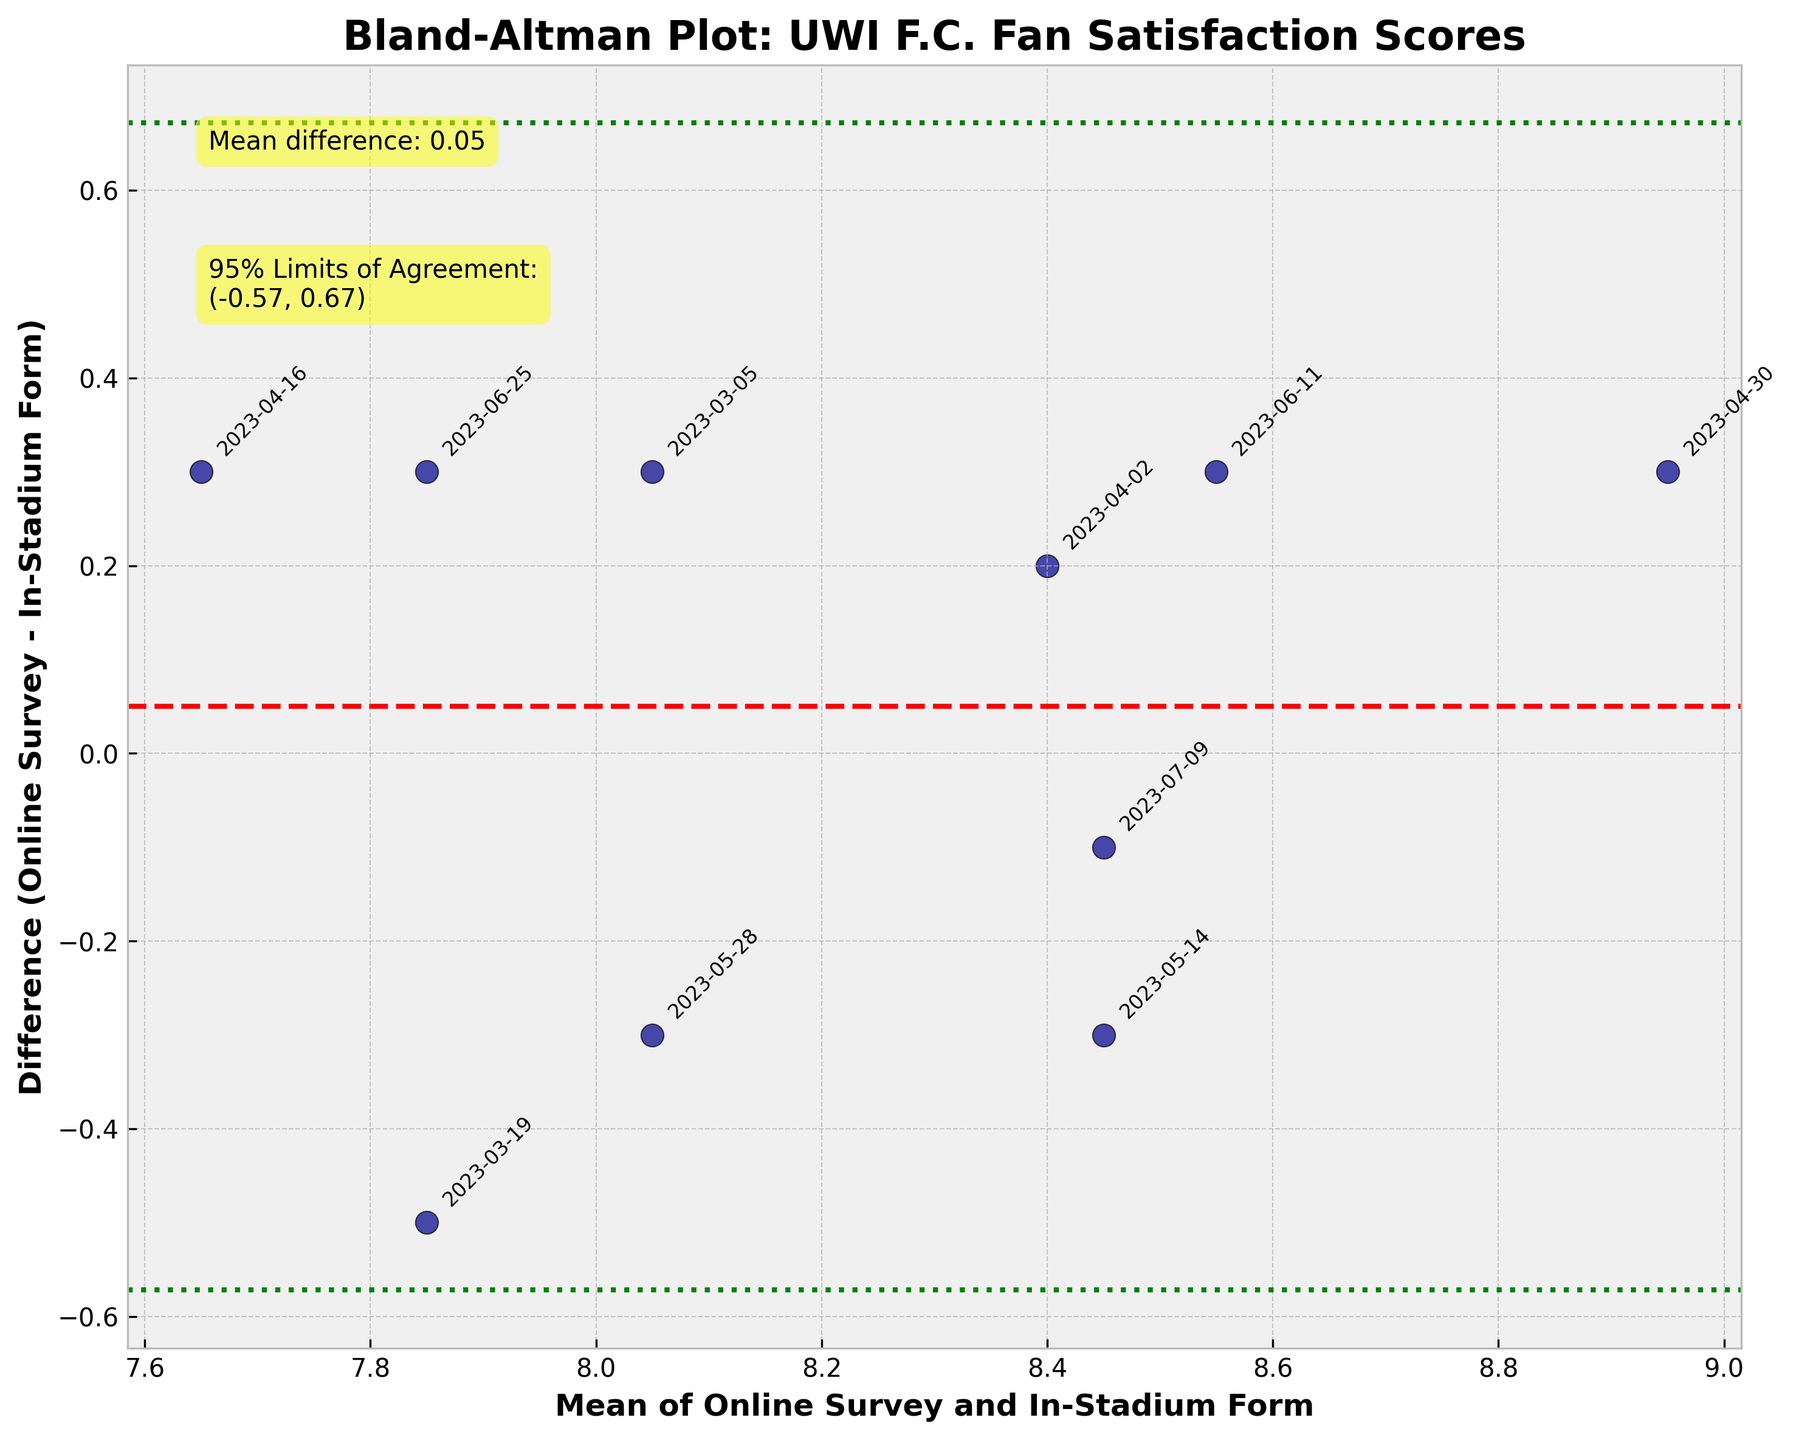How many data points are represented in the plot? By counting the number of points scattered on the plot, we can determine the number of data points. Each point corresponds to a match. There are 10 points on the plot.
Answer: 10 What is the title of the plot? The title of the plot is displayed at the top and usually describes the purpose or subject of the plot. It reads "Bland-Altman Plot: UWI F.C. Fan Satisfaction Scores".
Answer: Bland-Altman Plot: UWI F.C. Fan Satisfaction Scores What do the green dotted lines represent? In a Bland-Altman plot, the green dotted lines indicate the 95% limits of agreement. These lines show the range within which 95% of the differences between the two methods (online survey and in-stadium form) are expected to lie.
Answer: 95% limits of agreement What is the mean difference between the online survey and in-stadium form scores? The mean difference is represented by a red dashed line. The figure includes an annotation that reads "Mean difference: 0.04," indicating that the mean difference is 0.04.
Answer: 0.04 What range is indicated by the 95% limits of agreement? An annotation in the plot provides the range for the 95% limits of agreement. It reads "95% Limits of Agreement: (-0.42, 0.50)," indicating the range.
Answer: (-0.42, 0.50) During which match date did the largest negative difference occur? We can identify the largest negative difference by looking at the point furthest below the x-axis. The annotated match date closest to this point is "2023-06-25".
Answer: 2023-06-25 Which match date had the smallest difference between the online survey and in-stadium form scores? The smallest difference will be closest to the x-axis where the difference is near zero. The point closest to this line represents the match date "2023-07-09".
Answer: 2023-07-09 If a new data point had a mean score of 8.5 and a difference of 0.3, would it fall within the 95% limits of agreement? To check if a new data point falls within the 95% limits of agreement, we compare its difference to the limits. Since the point difference (0.3) is within the range (-0.42, 0.50), it would fall within these limits.
Answer: Yes Are there more differences above or below the mean difference line? By visually inspecting the plot, we can count the number of points above and below the red dashed mean difference line. There are more points below (total: 6) than above (total: 4).
Answer: Below What does a positive difference in the plot indicate? A positive difference means that the online survey score is higher than the in-stadium form score, as the difference is calculated as (Online Survey - In-Stadium Form).
Answer: Online survey score is higher 